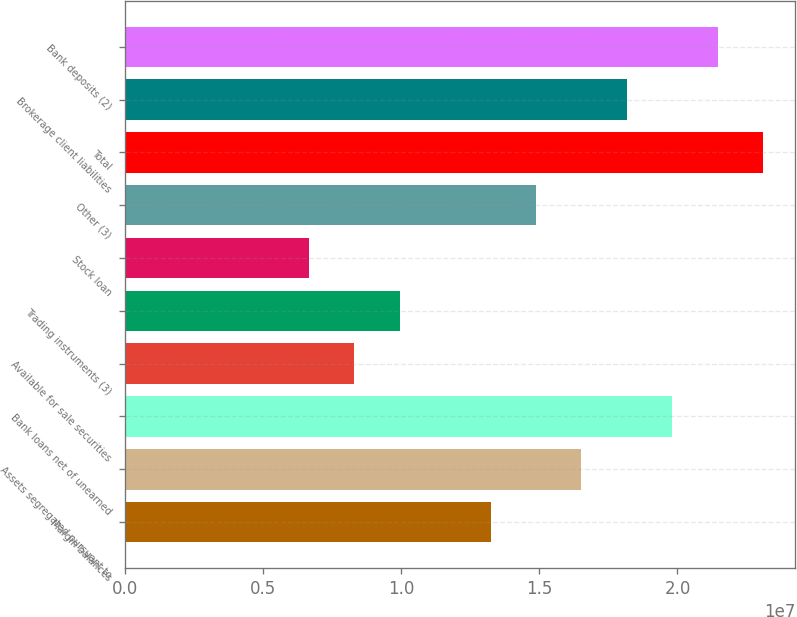<chart> <loc_0><loc_0><loc_500><loc_500><bar_chart><fcel>Margin balances<fcel>Assets segregated pursuant to<fcel>Bank loans net of unearned<fcel>Available for sale securities<fcel>Trading instruments (3)<fcel>Stock loan<fcel>Other (3)<fcel>Total<fcel>Brokerage client liabilities<fcel>Bank deposits (2)<nl><fcel>1.32377e+07<fcel>1.6525e+07<fcel>1.98122e+07<fcel>8.30688e+06<fcel>9.9505e+06<fcel>6.66325e+06<fcel>1.48814e+07<fcel>2.30995e+07<fcel>1.81686e+07<fcel>2.14559e+07<nl></chart> 